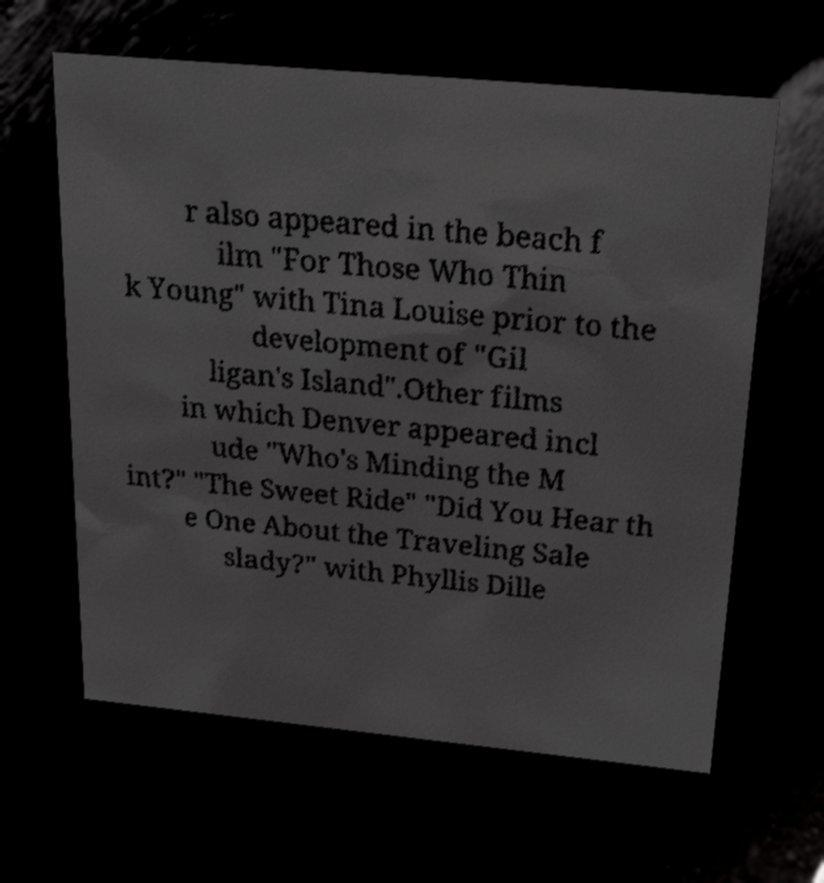There's text embedded in this image that I need extracted. Can you transcribe it verbatim? r also appeared in the beach f ilm "For Those Who Thin k Young" with Tina Louise prior to the development of "Gil ligan's Island".Other films in which Denver appeared incl ude "Who's Minding the M int?" "The Sweet Ride" "Did You Hear th e One About the Traveling Sale slady?" with Phyllis Dille 